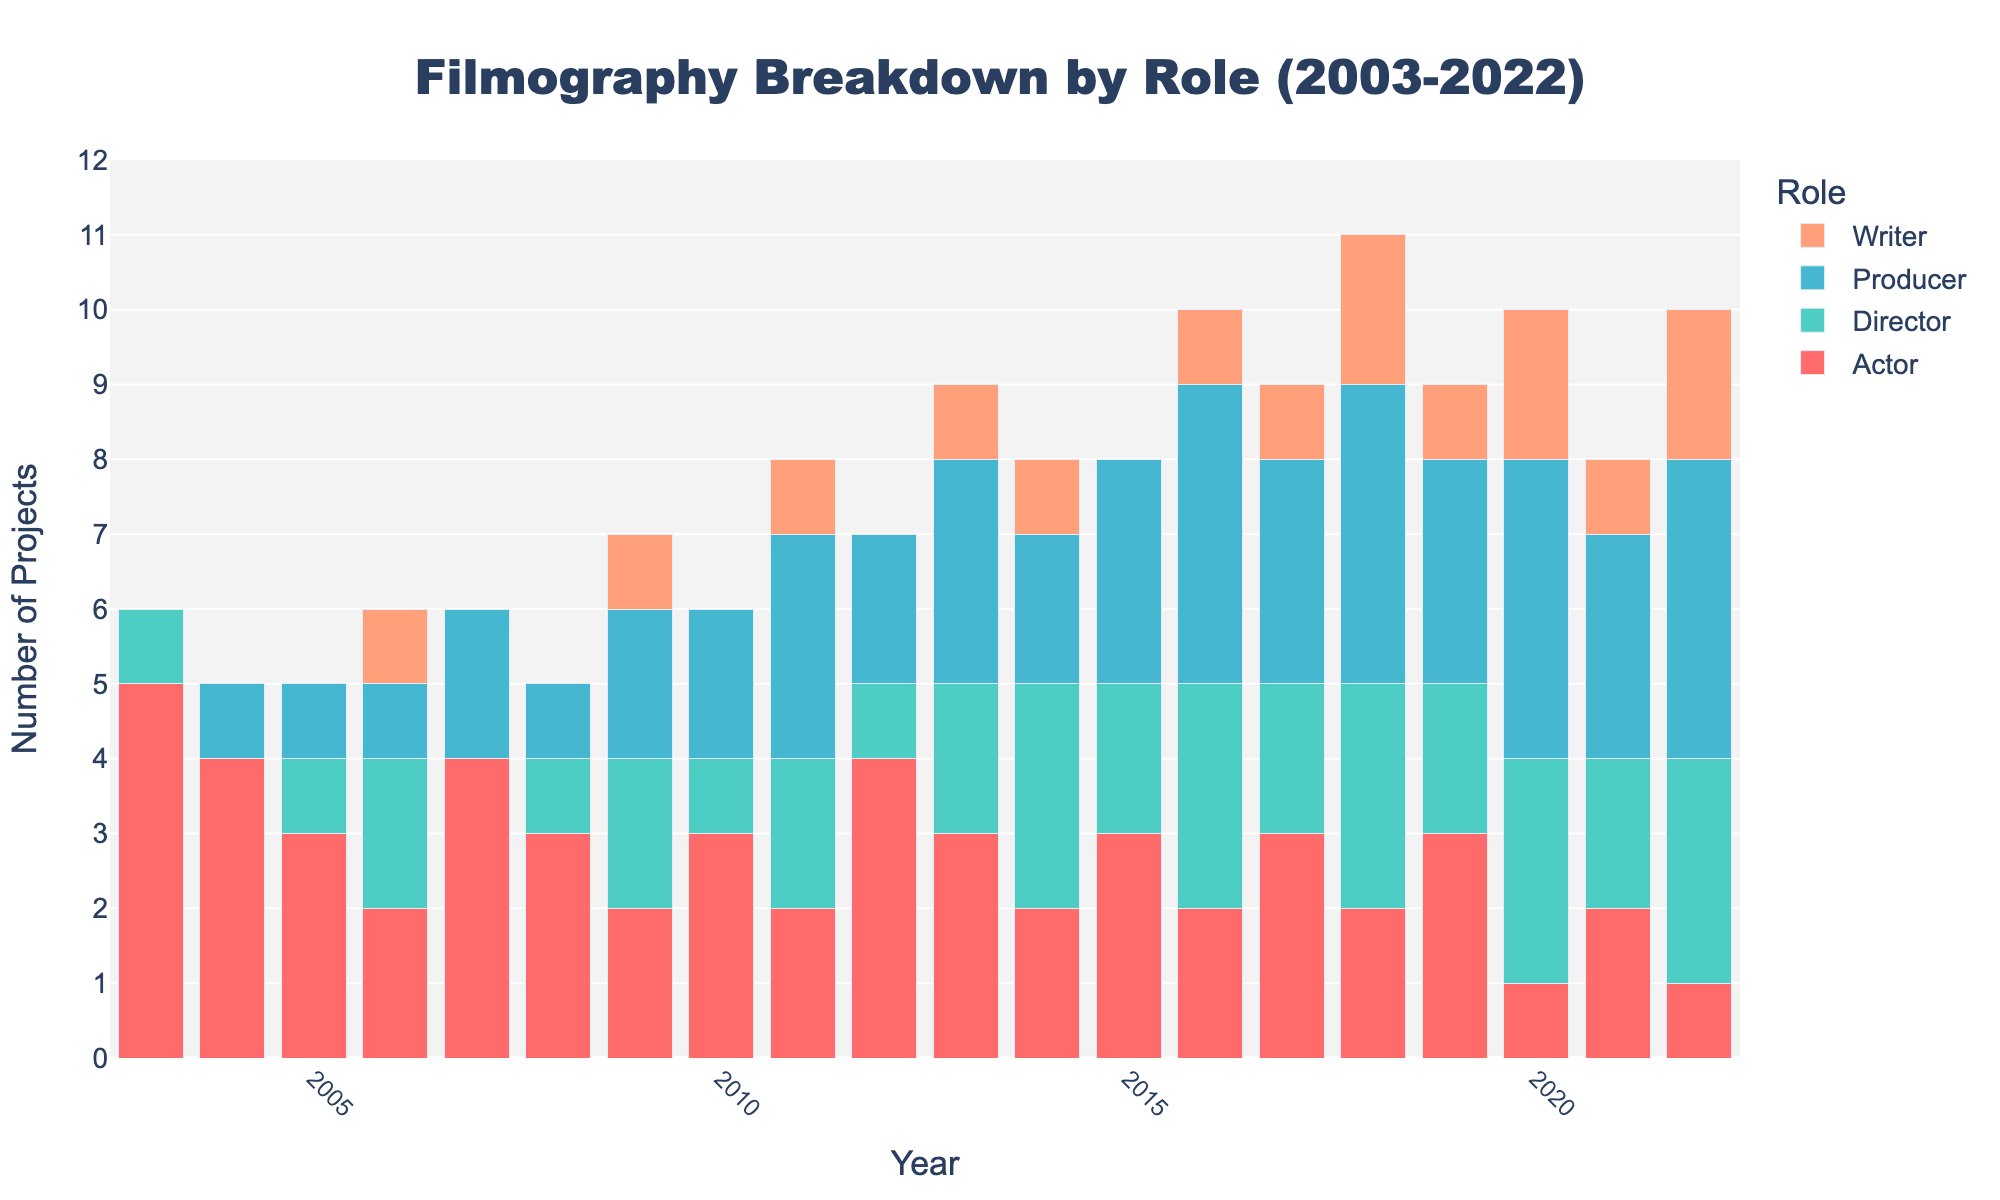Which year did the guest have the highest number of total projects? To determine the year with the highest number of total projects, sum the heights of all the stacked bars for each year and identify the year with the highest total count. The year 2013 stands out with a high sum.
Answer: 2013 In which year did the guest have more projects as a Director than as an Actor? Compare the heights of the bars representing the roles of Director and Actor for each year. In 2016, 2018, 2020, and 2022, the guest had more projects as a Director than as an Actor.
Answer: 2016, 2018, 2020, 2022 How many total projects did the guest work on as a Producer in the years 2006, 2007, and 2008 combined? Sum the heights of the "Producer" bars for each of the given years: 2006, 2007, and 2008. These amounts are 1, 2, and 1 respectively, giving a total of 1 + 2 + 1.
Answer: 4 What is the difference in the number of projects as a Writer between 2020 and 2006? Subtract the number of projects as a Writer in 2006 from the number of projects as a Writer in 2020: 2020 has 2 projects and 2006 has 1 project.
Answer: 1 Which role saw an increase in projects from 2009 to 2010? Compare the heights of the bars for each role between 2009 and 2010. The Producer role increased from 2 projects in 2009 to 3 projects in 2010.
Answer: Producer Among the roles "Actor" and "Director", which had fewer projects in 2021? Look at the heights of the "Actor" and "Director" bars for the year 2021: Actor has 2 projects, and Director has 2 projects.
Answer: Equal What is the average number of projects the guest worked on per year as a Writer from 2009 to 2022? Calculate the total number of Writer projects from 2009 to 2022, then divide by the number of years (14). The sum of Writer projects is 11, so the average is 11/14.
Answer: 0.79 Did the guest have more total projects in the first decade (2003 to 2012) or the second decade (2013 to 2022)? Sum the total number of projects for all roles from 2003 to 2012 and compare it to the sum from 2013 to 2022. The total for the first decade is 45, while for the second decade, it is 48.
Answer: Second decade 